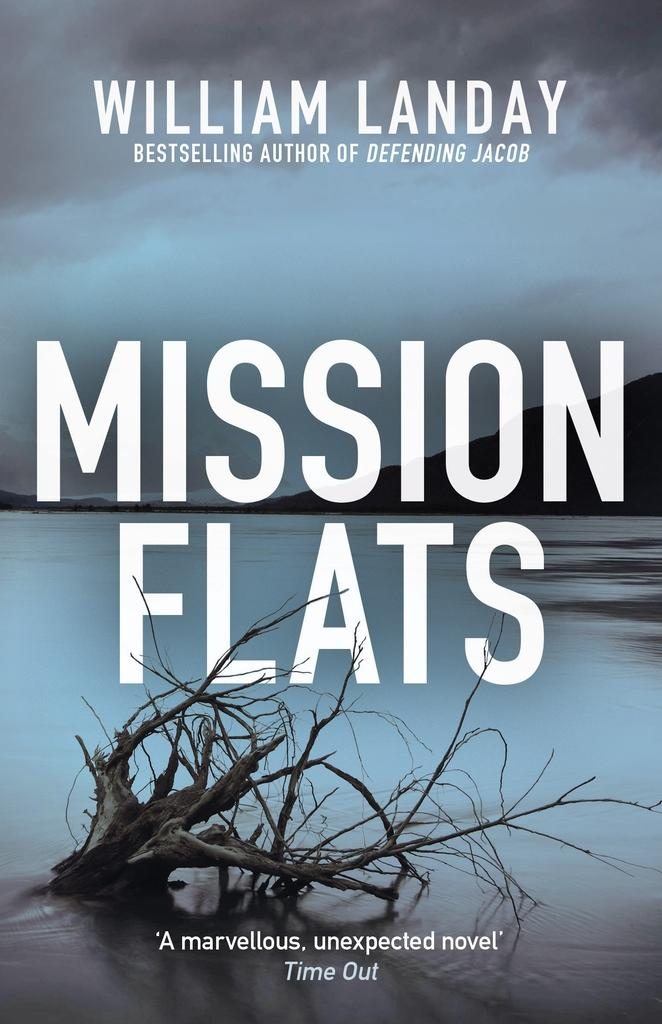<image>
Provide a brief description of the given image. A book by William Landy entitled Misson Flats. 